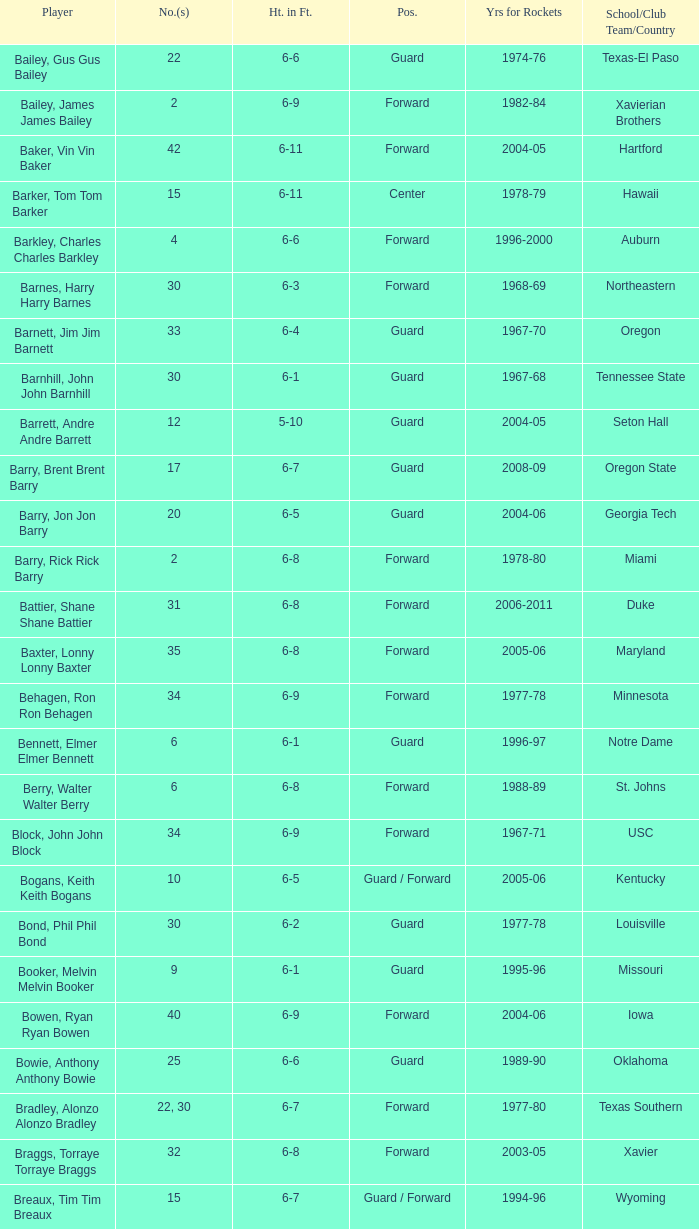What school did the forward whose number is 10 belong to? Arizona. 